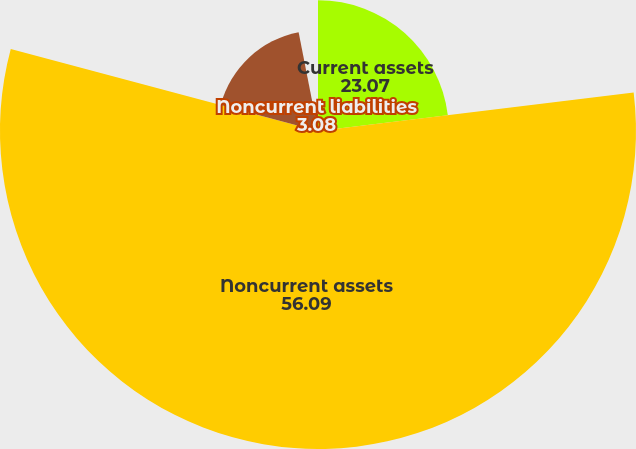Convert chart. <chart><loc_0><loc_0><loc_500><loc_500><pie_chart><fcel>Current assets<fcel>Noncurrent assets<fcel>Current liabilities<fcel>Noncurrent liabilities<nl><fcel>23.07%<fcel>56.09%<fcel>17.77%<fcel>3.08%<nl></chart> 